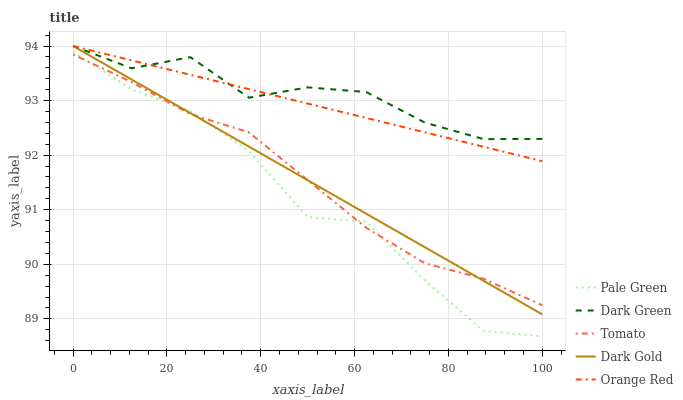Does Pale Green have the minimum area under the curve?
Answer yes or no. Yes. Does Dark Green have the maximum area under the curve?
Answer yes or no. Yes. Does Orange Red have the minimum area under the curve?
Answer yes or no. No. Does Orange Red have the maximum area under the curve?
Answer yes or no. No. Is Orange Red the smoothest?
Answer yes or no. Yes. Is Pale Green the roughest?
Answer yes or no. Yes. Is Pale Green the smoothest?
Answer yes or no. No. Is Orange Red the roughest?
Answer yes or no. No. Does Pale Green have the lowest value?
Answer yes or no. Yes. Does Orange Red have the lowest value?
Answer yes or no. No. Does Dark Green have the highest value?
Answer yes or no. Yes. Does Pale Green have the highest value?
Answer yes or no. No. Is Tomato less than Dark Green?
Answer yes or no. Yes. Is Dark Green greater than Pale Green?
Answer yes or no. Yes. Does Dark Gold intersect Pale Green?
Answer yes or no. Yes. Is Dark Gold less than Pale Green?
Answer yes or no. No. Is Dark Gold greater than Pale Green?
Answer yes or no. No. Does Tomato intersect Dark Green?
Answer yes or no. No. 